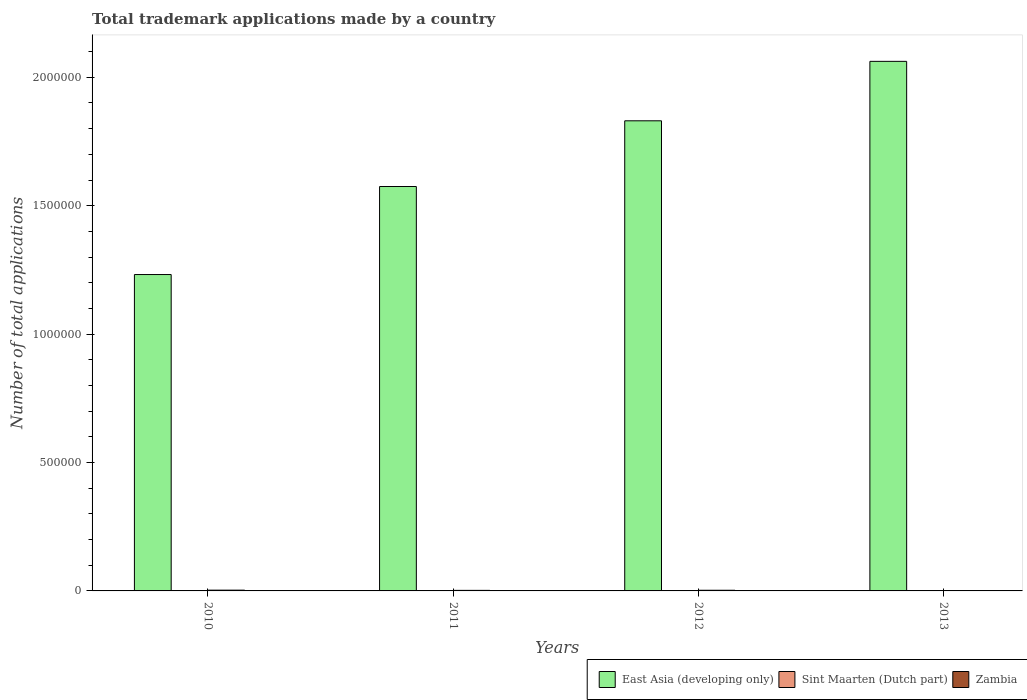How many different coloured bars are there?
Your response must be concise. 3. Are the number of bars per tick equal to the number of legend labels?
Your answer should be compact. Yes. Are the number of bars on each tick of the X-axis equal?
Offer a terse response. Yes. What is the number of applications made by in Sint Maarten (Dutch part) in 2010?
Provide a succinct answer. 35. Across all years, what is the maximum number of applications made by in East Asia (developing only)?
Provide a short and direct response. 2.06e+06. Across all years, what is the minimum number of applications made by in East Asia (developing only)?
Offer a very short reply. 1.23e+06. What is the total number of applications made by in East Asia (developing only) in the graph?
Give a very brief answer. 6.70e+06. What is the difference between the number of applications made by in Zambia in 2012 and that in 2013?
Offer a terse response. 1667. What is the difference between the number of applications made by in East Asia (developing only) in 2012 and the number of applications made by in Zambia in 2013?
Your answer should be very brief. 1.83e+06. What is the average number of applications made by in Zambia per year?
Your answer should be compact. 2176.25. In the year 2012, what is the difference between the number of applications made by in Zambia and number of applications made by in East Asia (developing only)?
Your answer should be compact. -1.83e+06. In how many years, is the number of applications made by in Sint Maarten (Dutch part) greater than 400000?
Offer a terse response. 0. What is the ratio of the number of applications made by in East Asia (developing only) in 2012 to that in 2013?
Your answer should be very brief. 0.89. What is the difference between the highest and the second highest number of applications made by in Zambia?
Offer a very short reply. 379. What is the difference between the highest and the lowest number of applications made by in Sint Maarten (Dutch part)?
Keep it short and to the point. 955. In how many years, is the number of applications made by in Zambia greater than the average number of applications made by in Zambia taken over all years?
Offer a terse response. 2. Is the sum of the number of applications made by in Zambia in 2010 and 2011 greater than the maximum number of applications made by in East Asia (developing only) across all years?
Ensure brevity in your answer.  No. What does the 3rd bar from the left in 2011 represents?
Keep it short and to the point. Zambia. What does the 2nd bar from the right in 2011 represents?
Ensure brevity in your answer.  Sint Maarten (Dutch part). Is it the case that in every year, the sum of the number of applications made by in Sint Maarten (Dutch part) and number of applications made by in Zambia is greater than the number of applications made by in East Asia (developing only)?
Offer a terse response. No. How many bars are there?
Ensure brevity in your answer.  12. What is the difference between two consecutive major ticks on the Y-axis?
Make the answer very short. 5.00e+05. How are the legend labels stacked?
Give a very brief answer. Horizontal. What is the title of the graph?
Ensure brevity in your answer.  Total trademark applications made by a country. Does "San Marino" appear as one of the legend labels in the graph?
Offer a terse response. No. What is the label or title of the Y-axis?
Your response must be concise. Number of total applications. What is the Number of total applications in East Asia (developing only) in 2010?
Keep it short and to the point. 1.23e+06. What is the Number of total applications of Sint Maarten (Dutch part) in 2010?
Your response must be concise. 35. What is the Number of total applications in Zambia in 2010?
Offer a very short reply. 2990. What is the Number of total applications of East Asia (developing only) in 2011?
Ensure brevity in your answer.  1.57e+06. What is the Number of total applications of Sint Maarten (Dutch part) in 2011?
Your answer should be very brief. 990. What is the Number of total applications in Zambia in 2011?
Give a very brief answer. 2160. What is the Number of total applications in East Asia (developing only) in 2012?
Your answer should be compact. 1.83e+06. What is the Number of total applications in Sint Maarten (Dutch part) in 2012?
Provide a short and direct response. 893. What is the Number of total applications in Zambia in 2012?
Offer a very short reply. 2611. What is the Number of total applications in East Asia (developing only) in 2013?
Provide a short and direct response. 2.06e+06. What is the Number of total applications of Sint Maarten (Dutch part) in 2013?
Offer a terse response. 945. What is the Number of total applications in Zambia in 2013?
Provide a succinct answer. 944. Across all years, what is the maximum Number of total applications of East Asia (developing only)?
Keep it short and to the point. 2.06e+06. Across all years, what is the maximum Number of total applications of Sint Maarten (Dutch part)?
Offer a very short reply. 990. Across all years, what is the maximum Number of total applications in Zambia?
Provide a short and direct response. 2990. Across all years, what is the minimum Number of total applications in East Asia (developing only)?
Keep it short and to the point. 1.23e+06. Across all years, what is the minimum Number of total applications in Sint Maarten (Dutch part)?
Offer a very short reply. 35. Across all years, what is the minimum Number of total applications of Zambia?
Provide a short and direct response. 944. What is the total Number of total applications of East Asia (developing only) in the graph?
Your answer should be compact. 6.70e+06. What is the total Number of total applications in Sint Maarten (Dutch part) in the graph?
Offer a very short reply. 2863. What is the total Number of total applications in Zambia in the graph?
Your response must be concise. 8705. What is the difference between the Number of total applications in East Asia (developing only) in 2010 and that in 2011?
Your answer should be very brief. -3.43e+05. What is the difference between the Number of total applications in Sint Maarten (Dutch part) in 2010 and that in 2011?
Ensure brevity in your answer.  -955. What is the difference between the Number of total applications of Zambia in 2010 and that in 2011?
Offer a terse response. 830. What is the difference between the Number of total applications in East Asia (developing only) in 2010 and that in 2012?
Offer a very short reply. -5.99e+05. What is the difference between the Number of total applications in Sint Maarten (Dutch part) in 2010 and that in 2012?
Offer a terse response. -858. What is the difference between the Number of total applications in Zambia in 2010 and that in 2012?
Keep it short and to the point. 379. What is the difference between the Number of total applications of East Asia (developing only) in 2010 and that in 2013?
Offer a terse response. -8.30e+05. What is the difference between the Number of total applications of Sint Maarten (Dutch part) in 2010 and that in 2013?
Keep it short and to the point. -910. What is the difference between the Number of total applications in Zambia in 2010 and that in 2013?
Offer a very short reply. 2046. What is the difference between the Number of total applications of East Asia (developing only) in 2011 and that in 2012?
Ensure brevity in your answer.  -2.56e+05. What is the difference between the Number of total applications in Sint Maarten (Dutch part) in 2011 and that in 2012?
Keep it short and to the point. 97. What is the difference between the Number of total applications of Zambia in 2011 and that in 2012?
Give a very brief answer. -451. What is the difference between the Number of total applications in East Asia (developing only) in 2011 and that in 2013?
Your response must be concise. -4.87e+05. What is the difference between the Number of total applications in Zambia in 2011 and that in 2013?
Offer a terse response. 1216. What is the difference between the Number of total applications in East Asia (developing only) in 2012 and that in 2013?
Provide a short and direct response. -2.31e+05. What is the difference between the Number of total applications in Sint Maarten (Dutch part) in 2012 and that in 2013?
Provide a short and direct response. -52. What is the difference between the Number of total applications of Zambia in 2012 and that in 2013?
Your answer should be compact. 1667. What is the difference between the Number of total applications in East Asia (developing only) in 2010 and the Number of total applications in Sint Maarten (Dutch part) in 2011?
Provide a succinct answer. 1.23e+06. What is the difference between the Number of total applications of East Asia (developing only) in 2010 and the Number of total applications of Zambia in 2011?
Ensure brevity in your answer.  1.23e+06. What is the difference between the Number of total applications in Sint Maarten (Dutch part) in 2010 and the Number of total applications in Zambia in 2011?
Provide a succinct answer. -2125. What is the difference between the Number of total applications of East Asia (developing only) in 2010 and the Number of total applications of Sint Maarten (Dutch part) in 2012?
Your response must be concise. 1.23e+06. What is the difference between the Number of total applications of East Asia (developing only) in 2010 and the Number of total applications of Zambia in 2012?
Provide a succinct answer. 1.23e+06. What is the difference between the Number of total applications of Sint Maarten (Dutch part) in 2010 and the Number of total applications of Zambia in 2012?
Ensure brevity in your answer.  -2576. What is the difference between the Number of total applications of East Asia (developing only) in 2010 and the Number of total applications of Sint Maarten (Dutch part) in 2013?
Keep it short and to the point. 1.23e+06. What is the difference between the Number of total applications of East Asia (developing only) in 2010 and the Number of total applications of Zambia in 2013?
Provide a succinct answer. 1.23e+06. What is the difference between the Number of total applications in Sint Maarten (Dutch part) in 2010 and the Number of total applications in Zambia in 2013?
Offer a very short reply. -909. What is the difference between the Number of total applications of East Asia (developing only) in 2011 and the Number of total applications of Sint Maarten (Dutch part) in 2012?
Give a very brief answer. 1.57e+06. What is the difference between the Number of total applications of East Asia (developing only) in 2011 and the Number of total applications of Zambia in 2012?
Make the answer very short. 1.57e+06. What is the difference between the Number of total applications in Sint Maarten (Dutch part) in 2011 and the Number of total applications in Zambia in 2012?
Your response must be concise. -1621. What is the difference between the Number of total applications of East Asia (developing only) in 2011 and the Number of total applications of Sint Maarten (Dutch part) in 2013?
Provide a succinct answer. 1.57e+06. What is the difference between the Number of total applications in East Asia (developing only) in 2011 and the Number of total applications in Zambia in 2013?
Ensure brevity in your answer.  1.57e+06. What is the difference between the Number of total applications in Sint Maarten (Dutch part) in 2011 and the Number of total applications in Zambia in 2013?
Provide a short and direct response. 46. What is the difference between the Number of total applications of East Asia (developing only) in 2012 and the Number of total applications of Sint Maarten (Dutch part) in 2013?
Make the answer very short. 1.83e+06. What is the difference between the Number of total applications of East Asia (developing only) in 2012 and the Number of total applications of Zambia in 2013?
Your response must be concise. 1.83e+06. What is the difference between the Number of total applications in Sint Maarten (Dutch part) in 2012 and the Number of total applications in Zambia in 2013?
Provide a succinct answer. -51. What is the average Number of total applications in East Asia (developing only) per year?
Provide a succinct answer. 1.67e+06. What is the average Number of total applications in Sint Maarten (Dutch part) per year?
Keep it short and to the point. 715.75. What is the average Number of total applications in Zambia per year?
Offer a very short reply. 2176.25. In the year 2010, what is the difference between the Number of total applications of East Asia (developing only) and Number of total applications of Sint Maarten (Dutch part)?
Provide a succinct answer. 1.23e+06. In the year 2010, what is the difference between the Number of total applications in East Asia (developing only) and Number of total applications in Zambia?
Give a very brief answer. 1.23e+06. In the year 2010, what is the difference between the Number of total applications in Sint Maarten (Dutch part) and Number of total applications in Zambia?
Ensure brevity in your answer.  -2955. In the year 2011, what is the difference between the Number of total applications in East Asia (developing only) and Number of total applications in Sint Maarten (Dutch part)?
Offer a very short reply. 1.57e+06. In the year 2011, what is the difference between the Number of total applications of East Asia (developing only) and Number of total applications of Zambia?
Your response must be concise. 1.57e+06. In the year 2011, what is the difference between the Number of total applications in Sint Maarten (Dutch part) and Number of total applications in Zambia?
Give a very brief answer. -1170. In the year 2012, what is the difference between the Number of total applications in East Asia (developing only) and Number of total applications in Sint Maarten (Dutch part)?
Your response must be concise. 1.83e+06. In the year 2012, what is the difference between the Number of total applications in East Asia (developing only) and Number of total applications in Zambia?
Make the answer very short. 1.83e+06. In the year 2012, what is the difference between the Number of total applications in Sint Maarten (Dutch part) and Number of total applications in Zambia?
Offer a terse response. -1718. In the year 2013, what is the difference between the Number of total applications in East Asia (developing only) and Number of total applications in Sint Maarten (Dutch part)?
Give a very brief answer. 2.06e+06. In the year 2013, what is the difference between the Number of total applications in East Asia (developing only) and Number of total applications in Zambia?
Give a very brief answer. 2.06e+06. In the year 2013, what is the difference between the Number of total applications in Sint Maarten (Dutch part) and Number of total applications in Zambia?
Give a very brief answer. 1. What is the ratio of the Number of total applications of East Asia (developing only) in 2010 to that in 2011?
Provide a short and direct response. 0.78. What is the ratio of the Number of total applications of Sint Maarten (Dutch part) in 2010 to that in 2011?
Offer a very short reply. 0.04. What is the ratio of the Number of total applications in Zambia in 2010 to that in 2011?
Provide a succinct answer. 1.38. What is the ratio of the Number of total applications in East Asia (developing only) in 2010 to that in 2012?
Your response must be concise. 0.67. What is the ratio of the Number of total applications of Sint Maarten (Dutch part) in 2010 to that in 2012?
Provide a short and direct response. 0.04. What is the ratio of the Number of total applications in Zambia in 2010 to that in 2012?
Ensure brevity in your answer.  1.15. What is the ratio of the Number of total applications in East Asia (developing only) in 2010 to that in 2013?
Ensure brevity in your answer.  0.6. What is the ratio of the Number of total applications of Sint Maarten (Dutch part) in 2010 to that in 2013?
Make the answer very short. 0.04. What is the ratio of the Number of total applications of Zambia in 2010 to that in 2013?
Give a very brief answer. 3.17. What is the ratio of the Number of total applications in East Asia (developing only) in 2011 to that in 2012?
Your answer should be very brief. 0.86. What is the ratio of the Number of total applications of Sint Maarten (Dutch part) in 2011 to that in 2012?
Keep it short and to the point. 1.11. What is the ratio of the Number of total applications in Zambia in 2011 to that in 2012?
Provide a short and direct response. 0.83. What is the ratio of the Number of total applications in East Asia (developing only) in 2011 to that in 2013?
Your answer should be compact. 0.76. What is the ratio of the Number of total applications of Sint Maarten (Dutch part) in 2011 to that in 2013?
Provide a short and direct response. 1.05. What is the ratio of the Number of total applications of Zambia in 2011 to that in 2013?
Your response must be concise. 2.29. What is the ratio of the Number of total applications of East Asia (developing only) in 2012 to that in 2013?
Provide a succinct answer. 0.89. What is the ratio of the Number of total applications in Sint Maarten (Dutch part) in 2012 to that in 2013?
Your answer should be very brief. 0.94. What is the ratio of the Number of total applications of Zambia in 2012 to that in 2013?
Your response must be concise. 2.77. What is the difference between the highest and the second highest Number of total applications in East Asia (developing only)?
Make the answer very short. 2.31e+05. What is the difference between the highest and the second highest Number of total applications in Zambia?
Offer a very short reply. 379. What is the difference between the highest and the lowest Number of total applications of East Asia (developing only)?
Keep it short and to the point. 8.30e+05. What is the difference between the highest and the lowest Number of total applications of Sint Maarten (Dutch part)?
Keep it short and to the point. 955. What is the difference between the highest and the lowest Number of total applications of Zambia?
Keep it short and to the point. 2046. 